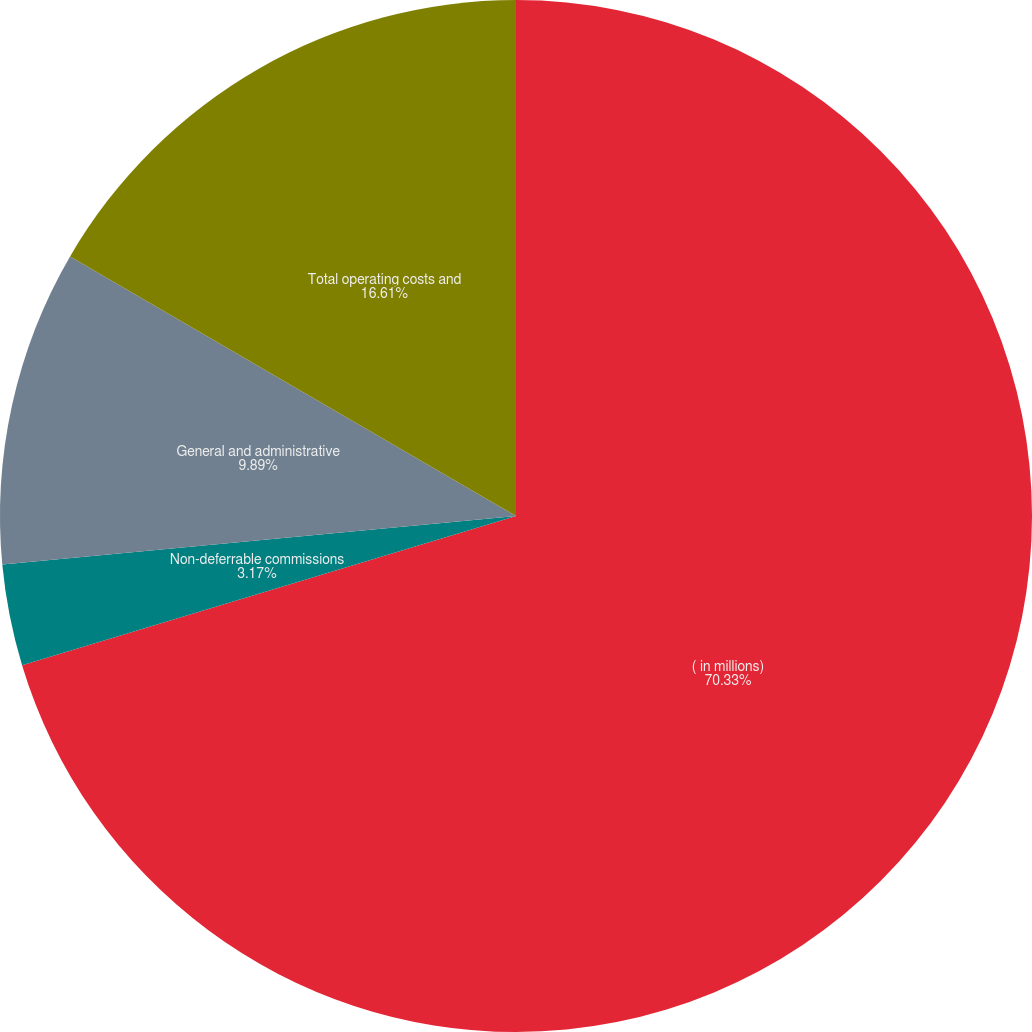Convert chart. <chart><loc_0><loc_0><loc_500><loc_500><pie_chart><fcel>( in millions)<fcel>Non-deferrable commissions<fcel>General and administrative<fcel>Total operating costs and<nl><fcel>70.33%<fcel>3.17%<fcel>9.89%<fcel>16.61%<nl></chart> 